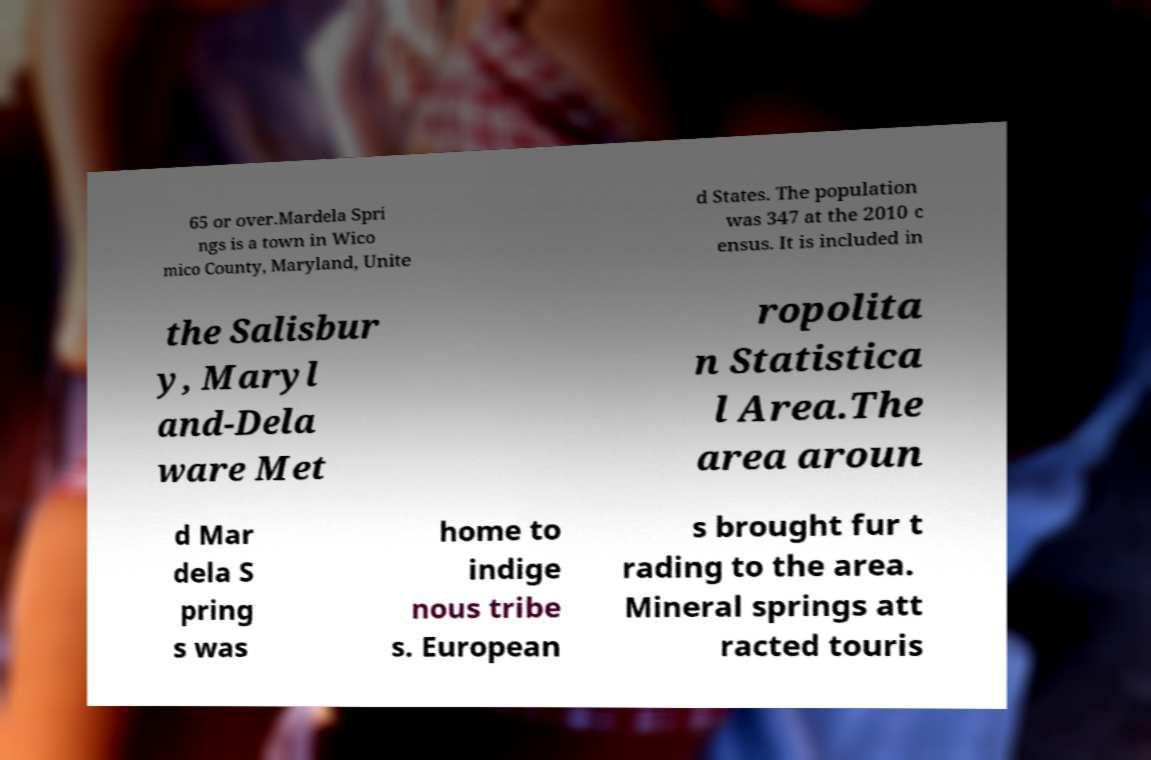I need the written content from this picture converted into text. Can you do that? 65 or over.Mardela Spri ngs is a town in Wico mico County, Maryland, Unite d States. The population was 347 at the 2010 c ensus. It is included in the Salisbur y, Maryl and-Dela ware Met ropolita n Statistica l Area.The area aroun d Mar dela S pring s was home to indige nous tribe s. European s brought fur t rading to the area. Mineral springs att racted touris 